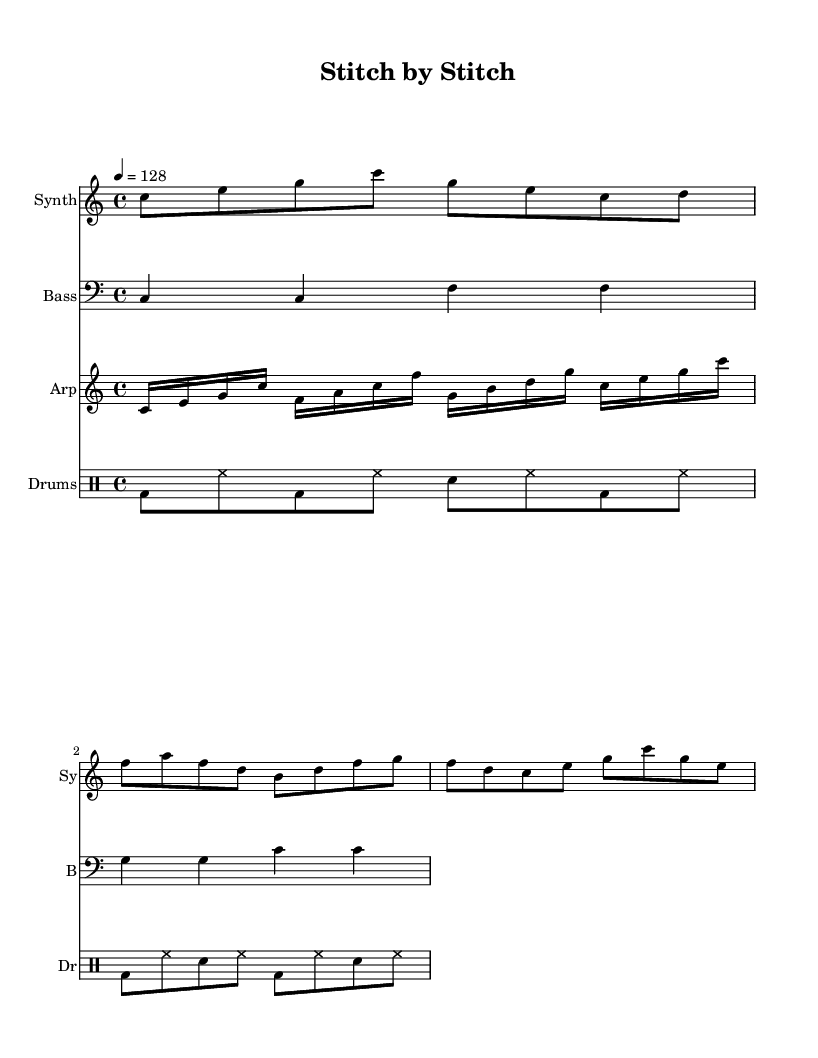What is the key signature of this music? The key signature is indicated by the absence of any sharps or flats at the beginning of the staff. This signifies the C major key.
Answer: C major What is the time signature of the piece? The time signature is shown as 4/4 at the beginning of the score, indicating a common time with four beats per measure, where each quarter note receives one beat.
Answer: 4/4 What is the tempo marking of the piece? The tempo marking of "4 = 128" indicates that there are 128 beats per minute, guiding the performer to maintain this speed when playing.
Answer: 128 How many measures are present in the melody? By counting the individual measures separated by vertical bar lines in the melody staff, we find there are a total of 4 measures.
Answer: 4 What type of percussion instrument is indicated in the drum patterns? The notation shows "bd" for bass drum, "hh" for hi-hat, and "sn" for snare drum, all of which are classic percussion instruments used in electronic music.
Answer: Bass drum, hi-hat, snare drum What rhythmic pattern mimics sewing machine sounds in this piece? The drum patterns consist of a consistent alternating beat of bass drum and hi-hats, which collectively create a repetitive driving rhythm akin to the sound of a sewing machine.
Answer: Alternating beats How does the arpeggiator part contribute to the overall texture? The arpeggiator plays fast-paced sequences of notes, creating a layered and rich sound that complements the melody and adds rhythmic complexity to the electronic arrangement.
Answer: Rich sound 